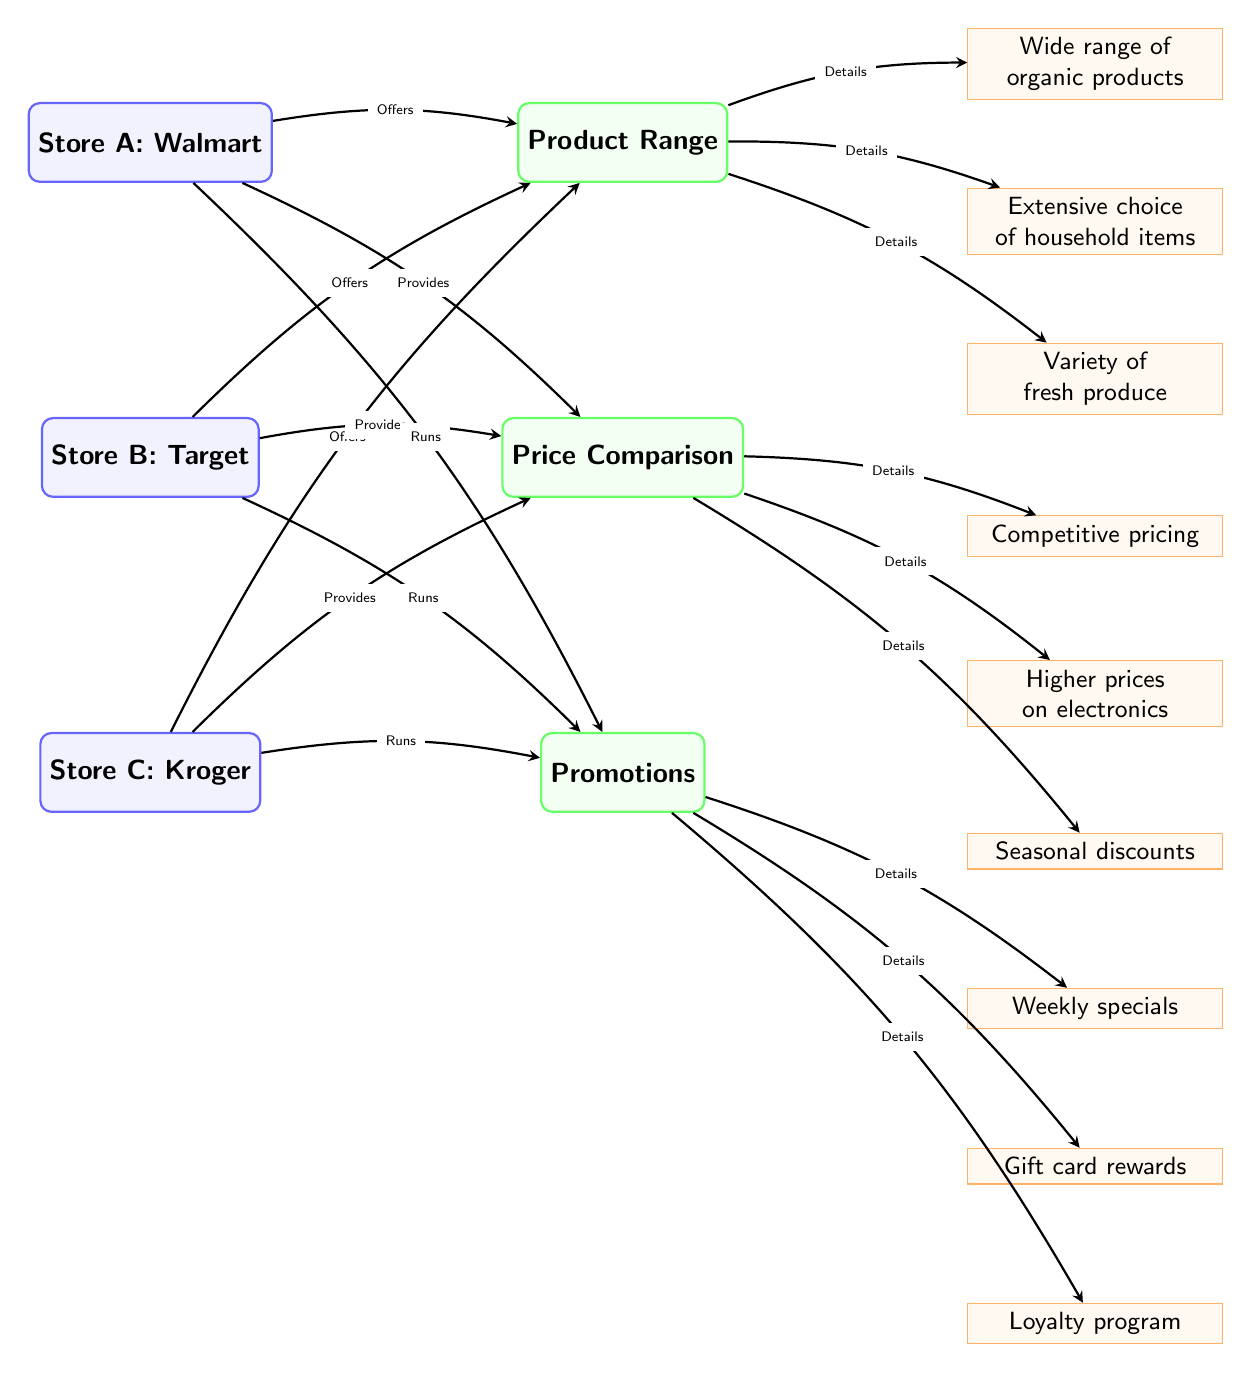What are the three stores listed in the diagram? The diagram lists three stores: Store A, Store B, and Store C. By counting the nodes labeled as "store" in the diagram, we identify them as Walmart, Target, and Kroger.
Answer: Walmart, Target, Kroger How many categories of competitive analysis are presented in the diagram? The diagram has three main categories named Product Range, Price Comparison, and Promotions. This can be confirmed by counting the nodes labeled as "category".
Answer: 3 What promotion does Store C run? Store C (Kroger) runs a loyalty program, which is indicated in the node connected to the "Promotions" category detailing its specific promotions.
Answer: Loyalty program Which store offers a wide range of organic products? Store A (Walmart) offers a wide range of organic products, as shown in the detail node connected to the "Product Range" category.
Answer: Walmart What does Store B provide according to the diagram? Store B (Target) provides competitive pricing, which is specified in the detail node under the "Price Comparison" category showing its pricing strategy.
Answer: Competitive pricing Which category is linked to the detail about seasonal discounts? The detail about seasonal discounts is linked to the Price Comparison category, as indicated by the edge connecting "Price Comparison" to its corresponding detail node.
Answer: Price Comparison Why might customers choose Store A based on the diagram? Customers might choose Store A (Walmart) because it offers a wide range of organic products, competitive pricing, and runs weekly specials, making it appealing in terms of product selection and savings. This combines the strengths shown across various categories in the diagram.
Answer: Wide range of organic products What relationship exists between Store A and the promotions they run? The relationship is that Store A runs weekly specials, which is shown as an edge connecting Store A to the "Promotions" category, indicating the specific promotional activities it engages in.
Answer: Runs How many details are provided under the category of Promotions? There are three details provided under the Promotions category: weekly specials, gift card rewards, and loyalty program. This can be determined by counting the detail nodes connected to the "Promotions" category in the diagram.
Answer: 3 